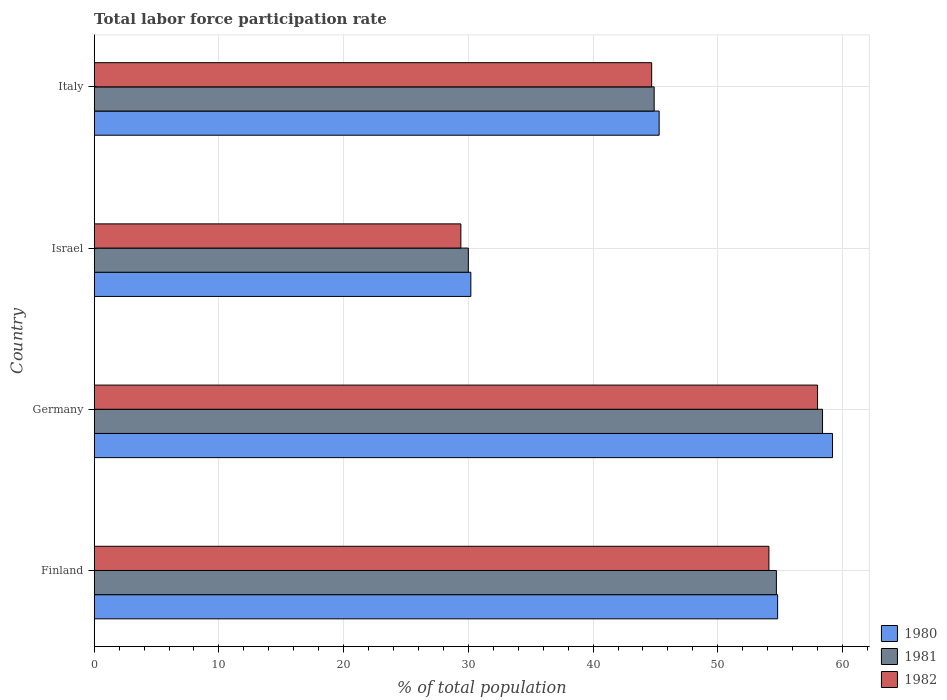How many different coloured bars are there?
Your answer should be compact. 3. Are the number of bars on each tick of the Y-axis equal?
Offer a terse response. Yes. How many bars are there on the 4th tick from the bottom?
Your answer should be very brief. 3. What is the total labor force participation rate in 1982 in Italy?
Make the answer very short. 44.7. Across all countries, what is the maximum total labor force participation rate in 1980?
Provide a succinct answer. 59.2. Across all countries, what is the minimum total labor force participation rate in 1980?
Ensure brevity in your answer.  30.2. In which country was the total labor force participation rate in 1981 minimum?
Make the answer very short. Israel. What is the total total labor force participation rate in 1980 in the graph?
Your answer should be very brief. 189.5. What is the difference between the total labor force participation rate in 1982 in Israel and that in Italy?
Keep it short and to the point. -15.3. What is the difference between the total labor force participation rate in 1980 in Israel and the total labor force participation rate in 1981 in Italy?
Provide a succinct answer. -14.7. What is the average total labor force participation rate in 1981 per country?
Provide a succinct answer. 47. What is the difference between the total labor force participation rate in 1980 and total labor force participation rate in 1982 in Israel?
Ensure brevity in your answer.  0.8. What is the ratio of the total labor force participation rate in 1982 in Finland to that in Germany?
Keep it short and to the point. 0.93. What is the difference between the highest and the second highest total labor force participation rate in 1982?
Offer a very short reply. 3.9. What is the difference between the highest and the lowest total labor force participation rate in 1980?
Your response must be concise. 29. Is the sum of the total labor force participation rate in 1982 in Finland and Italy greater than the maximum total labor force participation rate in 1980 across all countries?
Offer a very short reply. Yes. What does the 1st bar from the bottom in Israel represents?
Offer a terse response. 1980. How many bars are there?
Your answer should be very brief. 12. Are all the bars in the graph horizontal?
Your answer should be compact. Yes. How many countries are there in the graph?
Provide a short and direct response. 4. Does the graph contain grids?
Your response must be concise. Yes. How many legend labels are there?
Provide a short and direct response. 3. How are the legend labels stacked?
Give a very brief answer. Vertical. What is the title of the graph?
Your response must be concise. Total labor force participation rate. Does "1983" appear as one of the legend labels in the graph?
Offer a very short reply. No. What is the label or title of the X-axis?
Provide a short and direct response. % of total population. What is the % of total population of 1980 in Finland?
Provide a succinct answer. 54.8. What is the % of total population of 1981 in Finland?
Provide a succinct answer. 54.7. What is the % of total population in 1982 in Finland?
Your response must be concise. 54.1. What is the % of total population of 1980 in Germany?
Your answer should be compact. 59.2. What is the % of total population of 1981 in Germany?
Your answer should be compact. 58.4. What is the % of total population of 1980 in Israel?
Offer a terse response. 30.2. What is the % of total population in 1981 in Israel?
Provide a short and direct response. 30. What is the % of total population of 1982 in Israel?
Give a very brief answer. 29.4. What is the % of total population in 1980 in Italy?
Make the answer very short. 45.3. What is the % of total population of 1981 in Italy?
Offer a very short reply. 44.9. What is the % of total population of 1982 in Italy?
Provide a succinct answer. 44.7. Across all countries, what is the maximum % of total population of 1980?
Provide a succinct answer. 59.2. Across all countries, what is the maximum % of total population of 1981?
Offer a terse response. 58.4. Across all countries, what is the minimum % of total population of 1980?
Give a very brief answer. 30.2. Across all countries, what is the minimum % of total population in 1982?
Your answer should be very brief. 29.4. What is the total % of total population in 1980 in the graph?
Offer a very short reply. 189.5. What is the total % of total population of 1981 in the graph?
Your answer should be compact. 188. What is the total % of total population in 1982 in the graph?
Make the answer very short. 186.2. What is the difference between the % of total population in 1982 in Finland and that in Germany?
Provide a short and direct response. -3.9. What is the difference between the % of total population in 1980 in Finland and that in Israel?
Offer a very short reply. 24.6. What is the difference between the % of total population in 1981 in Finland and that in Israel?
Offer a very short reply. 24.7. What is the difference between the % of total population in 1982 in Finland and that in Israel?
Your answer should be very brief. 24.7. What is the difference between the % of total population of 1980 in Germany and that in Israel?
Provide a succinct answer. 29. What is the difference between the % of total population of 1981 in Germany and that in Israel?
Your answer should be compact. 28.4. What is the difference between the % of total population of 1982 in Germany and that in Israel?
Your answer should be very brief. 28.6. What is the difference between the % of total population in 1980 in Germany and that in Italy?
Your answer should be very brief. 13.9. What is the difference between the % of total population of 1981 in Germany and that in Italy?
Ensure brevity in your answer.  13.5. What is the difference between the % of total population in 1980 in Israel and that in Italy?
Ensure brevity in your answer.  -15.1. What is the difference between the % of total population of 1981 in Israel and that in Italy?
Your answer should be compact. -14.9. What is the difference between the % of total population of 1982 in Israel and that in Italy?
Your answer should be very brief. -15.3. What is the difference between the % of total population of 1980 in Finland and the % of total population of 1981 in Israel?
Provide a short and direct response. 24.8. What is the difference between the % of total population of 1980 in Finland and the % of total population of 1982 in Israel?
Ensure brevity in your answer.  25.4. What is the difference between the % of total population in 1981 in Finland and the % of total population in 1982 in Israel?
Give a very brief answer. 25.3. What is the difference between the % of total population of 1980 in Finland and the % of total population of 1981 in Italy?
Give a very brief answer. 9.9. What is the difference between the % of total population in 1980 in Finland and the % of total population in 1982 in Italy?
Offer a very short reply. 10.1. What is the difference between the % of total population in 1981 in Finland and the % of total population in 1982 in Italy?
Your response must be concise. 10. What is the difference between the % of total population in 1980 in Germany and the % of total population in 1981 in Israel?
Offer a terse response. 29.2. What is the difference between the % of total population in 1980 in Germany and the % of total population in 1982 in Israel?
Keep it short and to the point. 29.8. What is the difference between the % of total population of 1980 in Germany and the % of total population of 1981 in Italy?
Offer a terse response. 14.3. What is the difference between the % of total population of 1980 in Germany and the % of total population of 1982 in Italy?
Keep it short and to the point. 14.5. What is the difference between the % of total population in 1981 in Germany and the % of total population in 1982 in Italy?
Your response must be concise. 13.7. What is the difference between the % of total population in 1980 in Israel and the % of total population in 1981 in Italy?
Your answer should be very brief. -14.7. What is the difference between the % of total population in 1981 in Israel and the % of total population in 1982 in Italy?
Your response must be concise. -14.7. What is the average % of total population of 1980 per country?
Offer a terse response. 47.38. What is the average % of total population in 1982 per country?
Your answer should be very brief. 46.55. What is the difference between the % of total population of 1981 and % of total population of 1982 in Finland?
Offer a terse response. 0.6. What is the difference between the % of total population in 1980 and % of total population in 1982 in Germany?
Provide a short and direct response. 1.2. What is the difference between the % of total population of 1981 and % of total population of 1982 in Germany?
Give a very brief answer. 0.4. What is the difference between the % of total population of 1980 and % of total population of 1982 in Israel?
Ensure brevity in your answer.  0.8. What is the difference between the % of total population in 1981 and % of total population in 1982 in Israel?
Offer a terse response. 0.6. What is the difference between the % of total population of 1980 and % of total population of 1981 in Italy?
Provide a succinct answer. 0.4. What is the ratio of the % of total population in 1980 in Finland to that in Germany?
Your response must be concise. 0.93. What is the ratio of the % of total population in 1981 in Finland to that in Germany?
Keep it short and to the point. 0.94. What is the ratio of the % of total population of 1982 in Finland to that in Germany?
Your answer should be very brief. 0.93. What is the ratio of the % of total population of 1980 in Finland to that in Israel?
Provide a short and direct response. 1.81. What is the ratio of the % of total population in 1981 in Finland to that in Israel?
Offer a terse response. 1.82. What is the ratio of the % of total population in 1982 in Finland to that in Israel?
Your response must be concise. 1.84. What is the ratio of the % of total population of 1980 in Finland to that in Italy?
Offer a very short reply. 1.21. What is the ratio of the % of total population in 1981 in Finland to that in Italy?
Make the answer very short. 1.22. What is the ratio of the % of total population of 1982 in Finland to that in Italy?
Keep it short and to the point. 1.21. What is the ratio of the % of total population in 1980 in Germany to that in Israel?
Give a very brief answer. 1.96. What is the ratio of the % of total population in 1981 in Germany to that in Israel?
Your response must be concise. 1.95. What is the ratio of the % of total population of 1982 in Germany to that in Israel?
Provide a succinct answer. 1.97. What is the ratio of the % of total population of 1980 in Germany to that in Italy?
Provide a short and direct response. 1.31. What is the ratio of the % of total population of 1981 in Germany to that in Italy?
Make the answer very short. 1.3. What is the ratio of the % of total population in 1982 in Germany to that in Italy?
Keep it short and to the point. 1.3. What is the ratio of the % of total population of 1980 in Israel to that in Italy?
Your answer should be compact. 0.67. What is the ratio of the % of total population of 1981 in Israel to that in Italy?
Your answer should be compact. 0.67. What is the ratio of the % of total population of 1982 in Israel to that in Italy?
Keep it short and to the point. 0.66. What is the difference between the highest and the second highest % of total population of 1980?
Make the answer very short. 4.4. What is the difference between the highest and the second highest % of total population of 1982?
Ensure brevity in your answer.  3.9. What is the difference between the highest and the lowest % of total population in 1981?
Offer a terse response. 28.4. What is the difference between the highest and the lowest % of total population of 1982?
Keep it short and to the point. 28.6. 